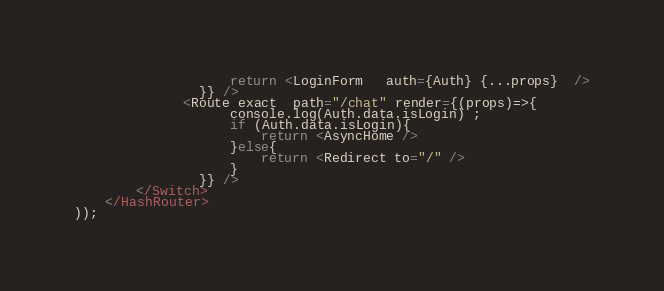Convert code to text. <code><loc_0><loc_0><loc_500><loc_500><_JavaScript_>                    return <LoginForm   auth={Auth} {...props}  />
                }} />
              <Route exact  path="/chat" render={(props)=>{
                    console.log(Auth.data.isLogin) ;
                    if (Auth.data.isLogin){
                        return <AsyncHome />
                    }else{
                        return <Redirect to="/" />
                    }
                }} />
        </Switch>
    </HashRouter>
));
</code> 